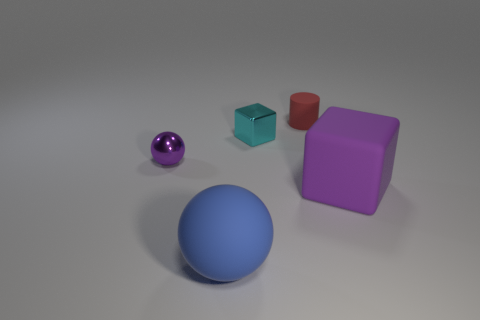Subtract all purple blocks. How many blocks are left? 1 Add 2 matte spheres. How many objects exist? 7 Subtract all cylinders. How many objects are left? 4 Subtract 1 spheres. How many spheres are left? 1 Add 4 spheres. How many spheres are left? 6 Add 1 tiny cylinders. How many tiny cylinders exist? 2 Subtract 0 cyan balls. How many objects are left? 5 Subtract all cyan spheres. Subtract all gray blocks. How many spheres are left? 2 Subtract all purple shiny balls. Subtract all red cylinders. How many objects are left? 3 